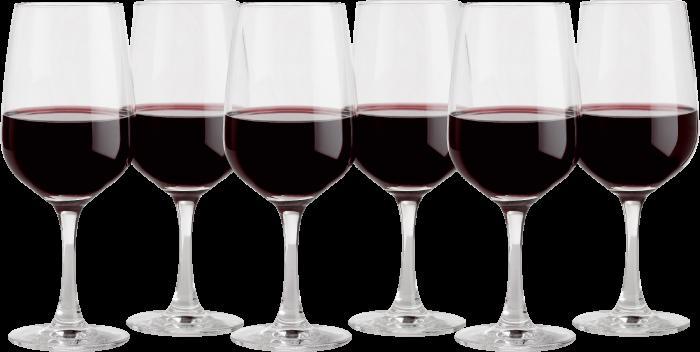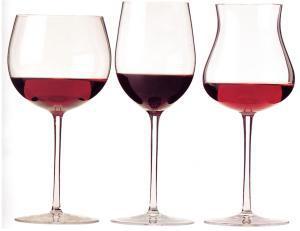The first image is the image on the left, the second image is the image on the right. Analyze the images presented: Is the assertion "One of the images has exactly three partially filled glasses." valid? Answer yes or no. Yes. The first image is the image on the left, the second image is the image on the right. Evaluate the accuracy of this statement regarding the images: "the image on the left has a wine glass next to the bottle". Is it true? Answer yes or no. No. 